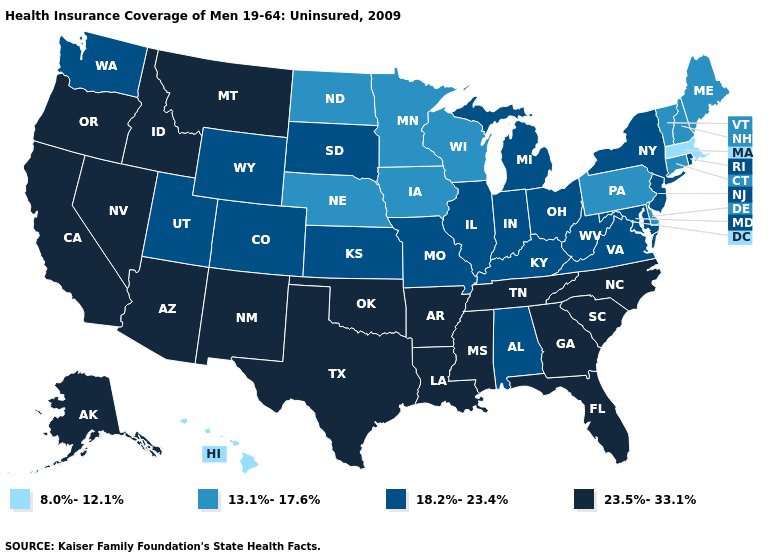What is the lowest value in the West?
Give a very brief answer. 8.0%-12.1%. Does Massachusetts have the same value as Hawaii?
Keep it brief. Yes. What is the value of Illinois?
Concise answer only. 18.2%-23.4%. Among the states that border West Virginia , does Pennsylvania have the lowest value?
Concise answer only. Yes. What is the value of Rhode Island?
Quick response, please. 18.2%-23.4%. Does New Jersey have the highest value in the Northeast?
Answer briefly. Yes. How many symbols are there in the legend?
Give a very brief answer. 4. What is the highest value in the USA?
Give a very brief answer. 23.5%-33.1%. Does Virginia have a higher value than New Hampshire?
Keep it brief. Yes. Name the states that have a value in the range 8.0%-12.1%?
Quick response, please. Hawaii, Massachusetts. Among the states that border California , which have the lowest value?
Give a very brief answer. Arizona, Nevada, Oregon. Among the states that border New York , which have the highest value?
Be succinct. New Jersey. What is the value of South Carolina?
Be succinct. 23.5%-33.1%. Name the states that have a value in the range 23.5%-33.1%?
Give a very brief answer. Alaska, Arizona, Arkansas, California, Florida, Georgia, Idaho, Louisiana, Mississippi, Montana, Nevada, New Mexico, North Carolina, Oklahoma, Oregon, South Carolina, Tennessee, Texas. Name the states that have a value in the range 13.1%-17.6%?
Concise answer only. Connecticut, Delaware, Iowa, Maine, Minnesota, Nebraska, New Hampshire, North Dakota, Pennsylvania, Vermont, Wisconsin. 